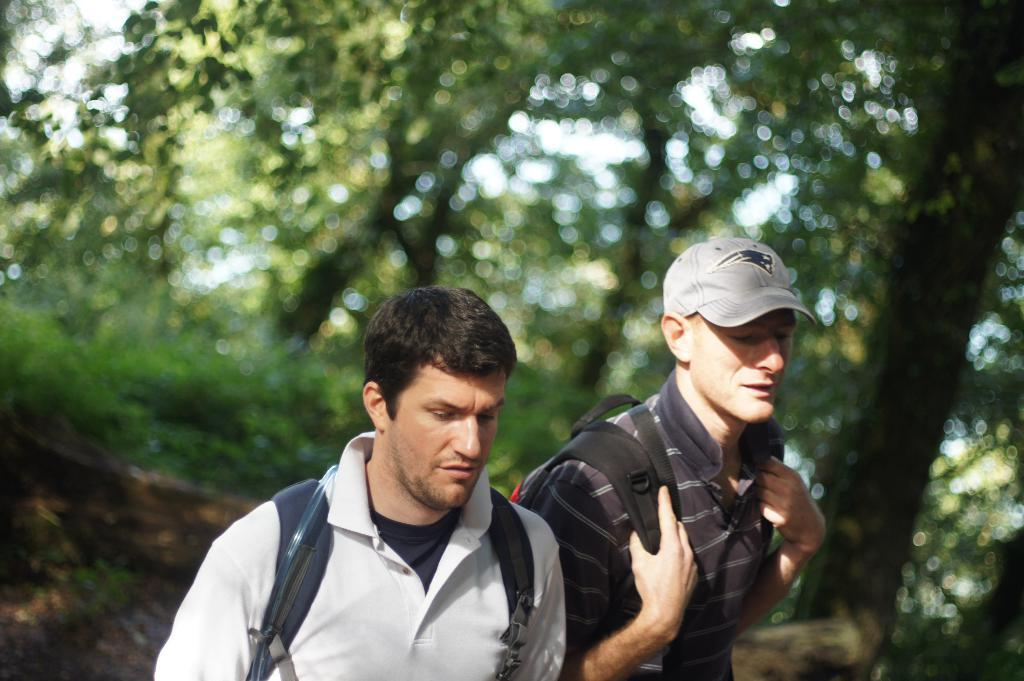How many people are in the image? There are two persons in the image. What are the persons carrying? The persons are carrying backpacks. What can be seen in the background of the image? There are trees in the background of the image. What type of drug is the minister using in the image? There is no minister or drug present in the image. What is the size of the nose on the person in the image? The size of the nose on the person in the image cannot be determined from the provided facts, as the image does not focus on the person's nose. 